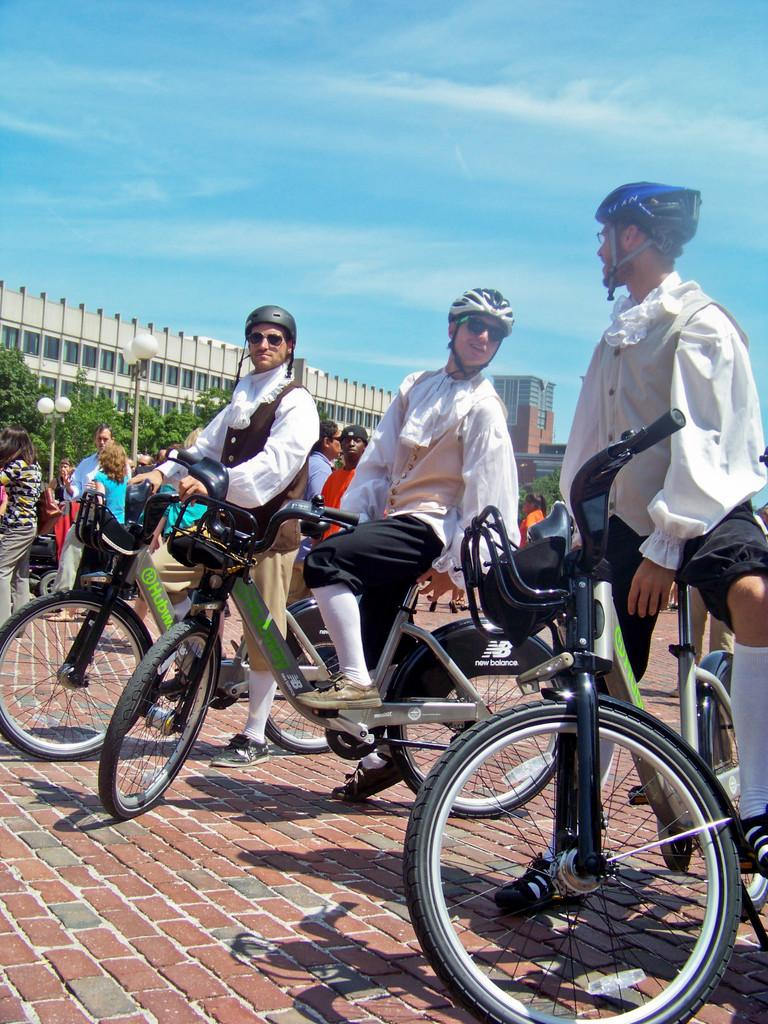How many persons are in the image? There are six persons in the image, three standing and three sitting. What are the sitting persons doing? The three sitting persons are holding a bicycle. What safety precaution are the sitting persons taking? The three sitting persons are wearing helmets. What can be seen in the background of the image? There is a building, trees, a pole, a light, and the sky visible in the background of the image. What type of operation is being performed on the root in the image? There is no operation or root present in the image. 